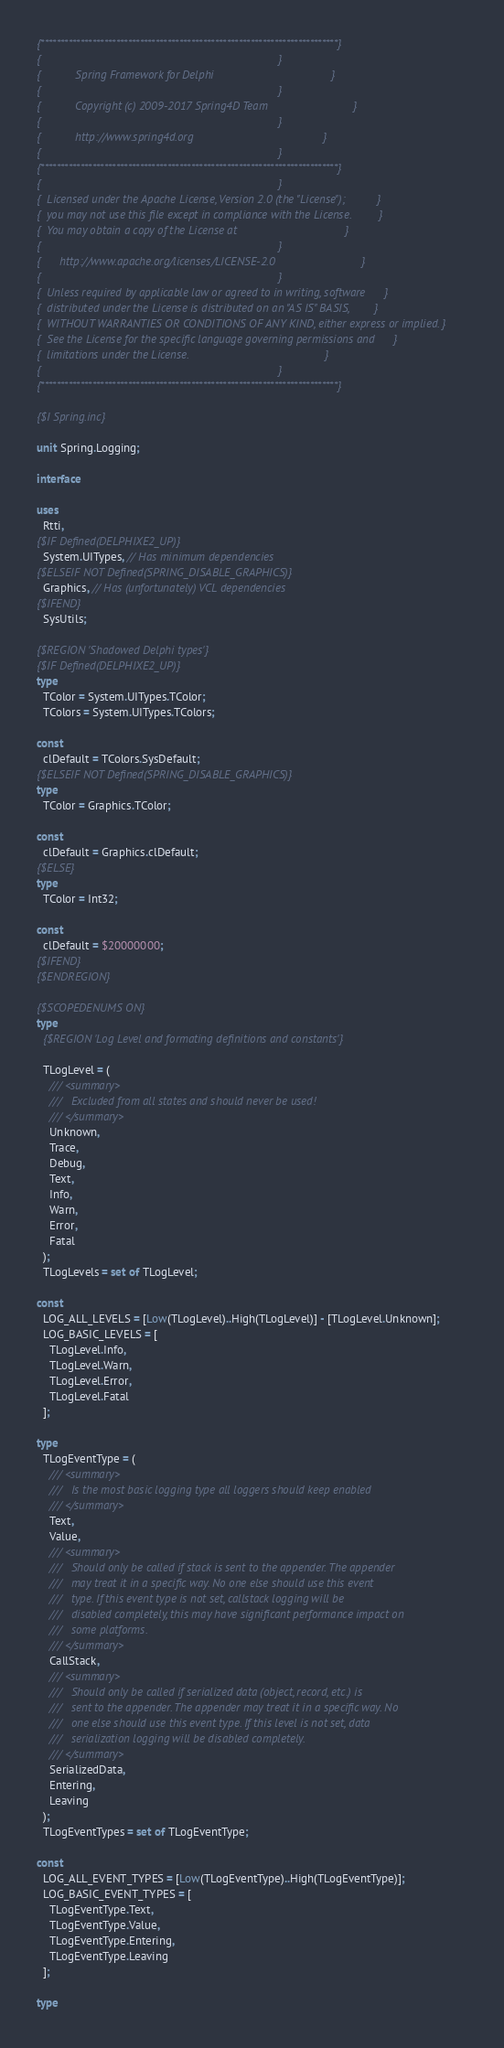<code> <loc_0><loc_0><loc_500><loc_500><_Pascal_>{***************************************************************************}
{                                                                           }
{           Spring Framework for Delphi                                     }
{                                                                           }
{           Copyright (c) 2009-2017 Spring4D Team                           }
{                                                                           }
{           http://www.spring4d.org                                         }
{                                                                           }
{***************************************************************************}
{                                                                           }
{  Licensed under the Apache License, Version 2.0 (the "License");          }
{  you may not use this file except in compliance with the License.         }
{  You may obtain a copy of the License at                                  }
{                                                                           }
{      http://www.apache.org/licenses/LICENSE-2.0                           }
{                                                                           }
{  Unless required by applicable law or agreed to in writing, software      }
{  distributed under the License is distributed on an "AS IS" BASIS,        }
{  WITHOUT WARRANTIES OR CONDITIONS OF ANY KIND, either express or implied. }
{  See the License for the specific language governing permissions and      }
{  limitations under the License.                                           }
{                                                                           }
{***************************************************************************}

{$I Spring.inc}

unit Spring.Logging;

interface

uses
  Rtti,
{$IF Defined(DELPHIXE2_UP)}
  System.UITypes, // Has minimum dependencies
{$ELSEIF NOT Defined(SPRING_DISABLE_GRAPHICS)}
  Graphics, // Has (unfortunately) VCL dependencies
{$IFEND}
  SysUtils;

{$REGION 'Shadowed Delphi types'}
{$IF Defined(DELPHIXE2_UP)}
type
  TColor = System.UITypes.TColor;
  TColors = System.UITypes.TColors;

const
  clDefault = TColors.SysDefault;
{$ELSEIF NOT Defined(SPRING_DISABLE_GRAPHICS)}
type
  TColor = Graphics.TColor;

const
  clDefault = Graphics.clDefault;
{$ELSE}
type
  TColor = Int32;

const
  clDefault = $20000000;
{$IFEND}
{$ENDREGION}

{$SCOPEDENUMS ON}
type
  {$REGION 'Log Level and formating definitions and constants'}

  TLogLevel = (
    /// <summary>
    ///   Excluded from all states and should never be used!
    /// </summary>
    Unknown,
    Trace,
    Debug,
    Text,
    Info,
    Warn,
    Error,
    Fatal
  );
  TLogLevels = set of TLogLevel;

const
  LOG_ALL_LEVELS = [Low(TLogLevel)..High(TLogLevel)] - [TLogLevel.Unknown];
  LOG_BASIC_LEVELS = [
    TLogLevel.Info,
    TLogLevel.Warn,
    TLogLevel.Error,
    TLogLevel.Fatal
  ];

type
  TLogEventType = (
    /// <summary>
    ///   Is the most basic logging type all loggers should keep enabled
    /// </summary>
    Text,
    Value,
    /// <summary>
    ///   Should only be called if stack is sent to the appender. The appender
    ///   may treat it in a specific way. No one else should use this event
    ///   type. If this event type is not set, callstack logging will be
    ///   disabled completely, this may have significant performance impact on
    ///   some platforms.
    /// </summary>
    CallStack,
    /// <summary>
    ///   Should only be called if serialized data (object, record, etc.) is
    ///   sent to the appender. The appender may treat it in a specific way. No
    ///   one else should use this event type. If this level is not set, data
    ///   serialization logging will be disabled completely.
    /// </summary>
    SerializedData,
    Entering,
    Leaving
  );
  TLogEventTypes = set of TLogEventType;

const
  LOG_ALL_EVENT_TYPES = [Low(TLogEventType)..High(TLogEventType)];
  LOG_BASIC_EVENT_TYPES = [
    TLogEventType.Text,
    TLogEventType.Value,
    TLogEventType.Entering,
    TLogEventType.Leaving
  ];

type</code> 